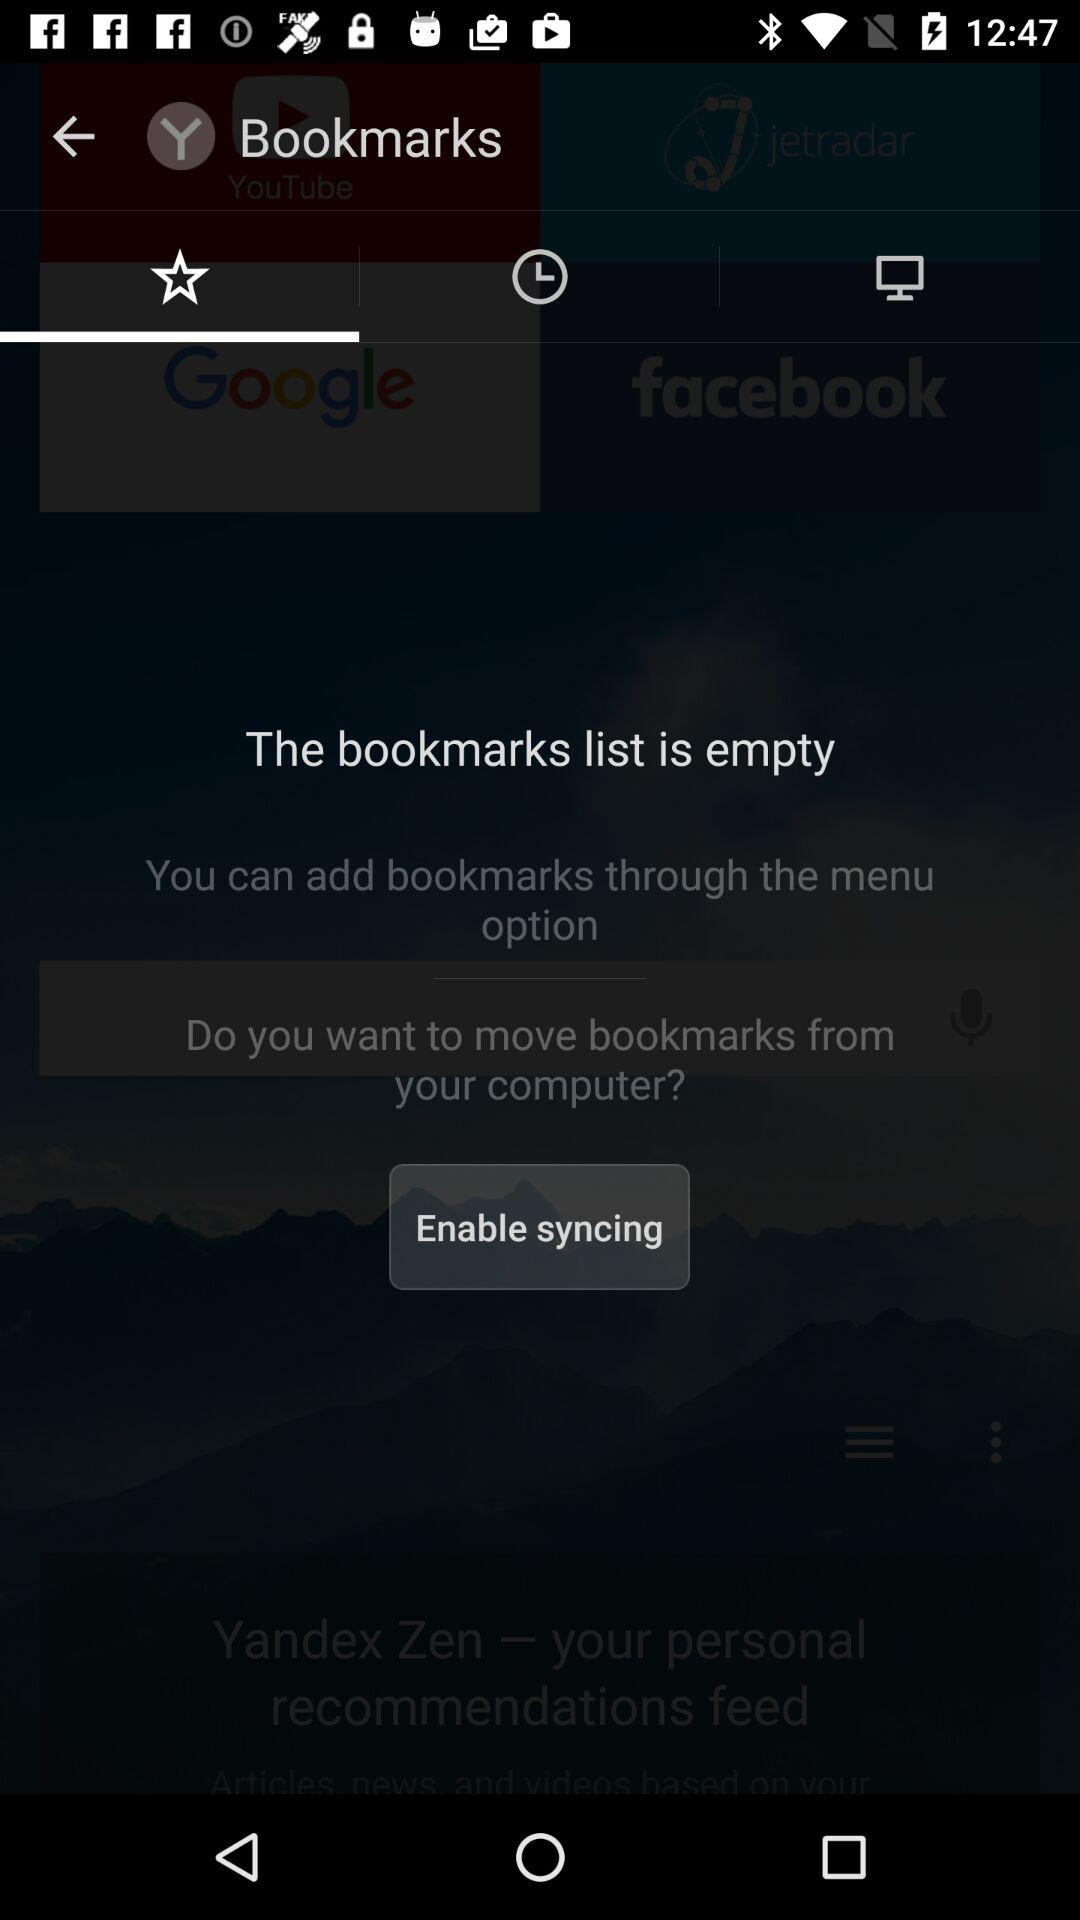Are there any bookmarks present in the list? The bookmarks list is empty. 